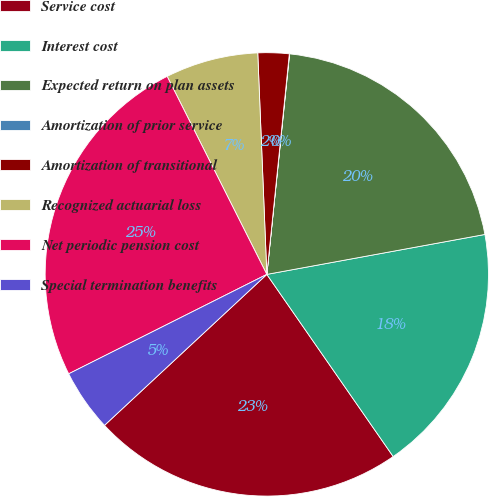Convert chart to OTSL. <chart><loc_0><loc_0><loc_500><loc_500><pie_chart><fcel>Service cost<fcel>Interest cost<fcel>Expected return on plan assets<fcel>Amortization of prior service<fcel>Amortization of transitional<fcel>Recognized actuarial loss<fcel>Net periodic pension cost<fcel>Special termination benefits<nl><fcel>22.73%<fcel>18.23%<fcel>20.48%<fcel>0.02%<fcel>2.27%<fcel>6.77%<fcel>24.98%<fcel>4.52%<nl></chart> 